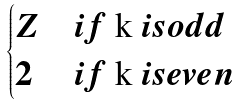Convert formula to latex. <formula><loc_0><loc_0><loc_500><loc_500>\begin{cases} Z & i f $ k $ i s o d d \\ 2 & i f $ k $ i s e v e n \end{cases}</formula> 